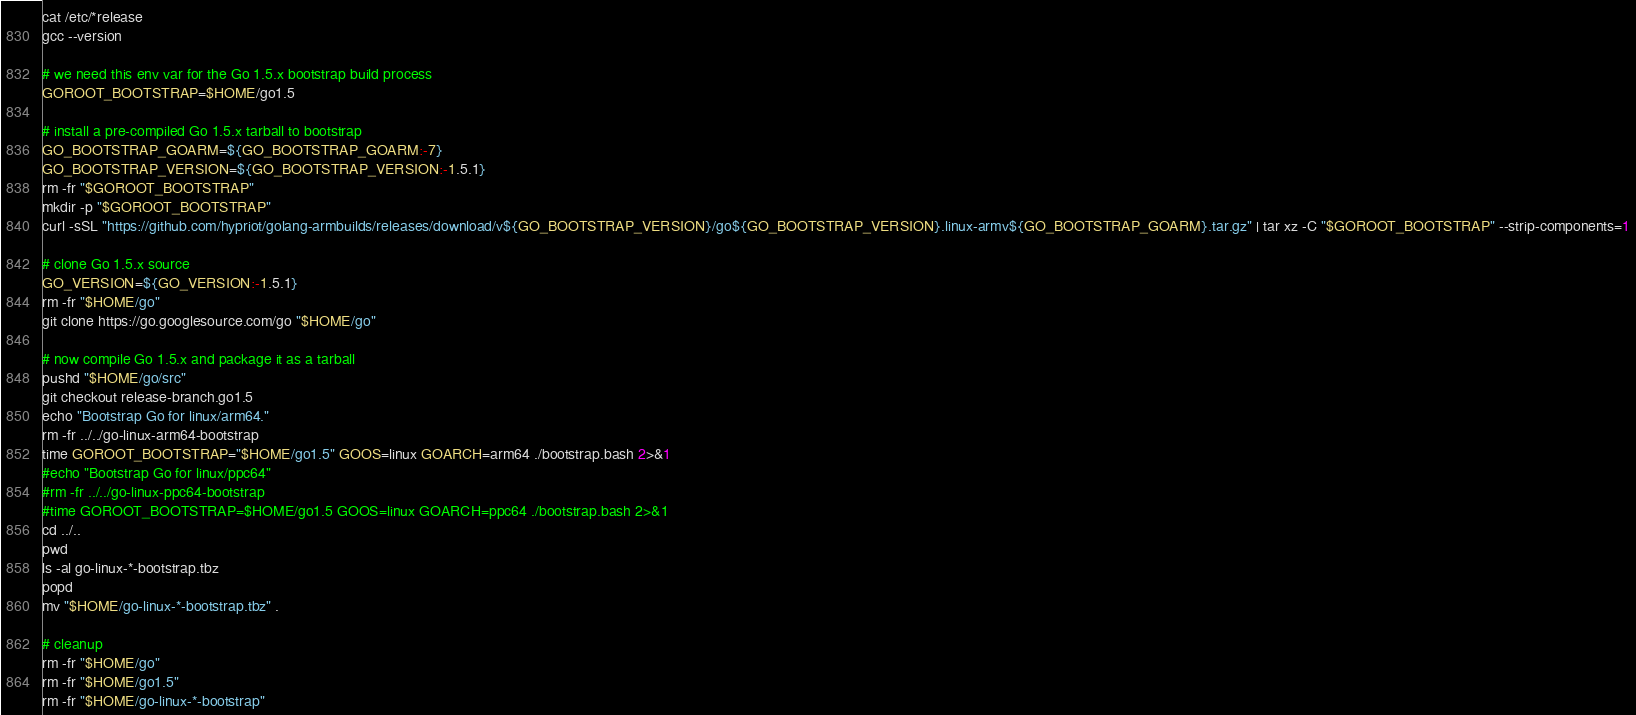Convert code to text. <code><loc_0><loc_0><loc_500><loc_500><_Bash_>cat /etc/*release
gcc --version

# we need this env var for the Go 1.5.x bootstrap build process
GOROOT_BOOTSTRAP=$HOME/go1.5

# install a pre-compiled Go 1.5.x tarball to bootstrap
GO_BOOTSTRAP_GOARM=${GO_BOOTSTRAP_GOARM:-7}
GO_BOOTSTRAP_VERSION=${GO_BOOTSTRAP_VERSION:-1.5.1}
rm -fr "$GOROOT_BOOTSTRAP"
mkdir -p "$GOROOT_BOOTSTRAP"
curl -sSL "https://github.com/hypriot/golang-armbuilds/releases/download/v${GO_BOOTSTRAP_VERSION}/go${GO_BOOTSTRAP_VERSION}.linux-armv${GO_BOOTSTRAP_GOARM}.tar.gz" | tar xz -C "$GOROOT_BOOTSTRAP" --strip-components=1

# clone Go 1.5.x source
GO_VERSION=${GO_VERSION:-1.5.1}
rm -fr "$HOME/go"
git clone https://go.googlesource.com/go "$HOME/go"

# now compile Go 1.5.x and package it as a tarball
pushd "$HOME/go/src"
git checkout release-branch.go1.5
echo "Bootstrap Go for linux/arm64."
rm -fr ../../go-linux-arm64-bootstrap
time GOROOT_BOOTSTRAP="$HOME/go1.5" GOOS=linux GOARCH=arm64 ./bootstrap.bash 2>&1
#echo "Bootstrap Go for linux/ppc64"
#rm -fr ../../go-linux-ppc64-bootstrap
#time GOROOT_BOOTSTRAP=$HOME/go1.5 GOOS=linux GOARCH=ppc64 ./bootstrap.bash 2>&1
cd ../..
pwd
ls -al go-linux-*-bootstrap.tbz
popd
mv "$HOME/go-linux-*-bootstrap.tbz" .

# cleanup
rm -fr "$HOME/go"
rm -fr "$HOME/go1.5"
rm -fr "$HOME/go-linux-*-bootstrap"
</code> 